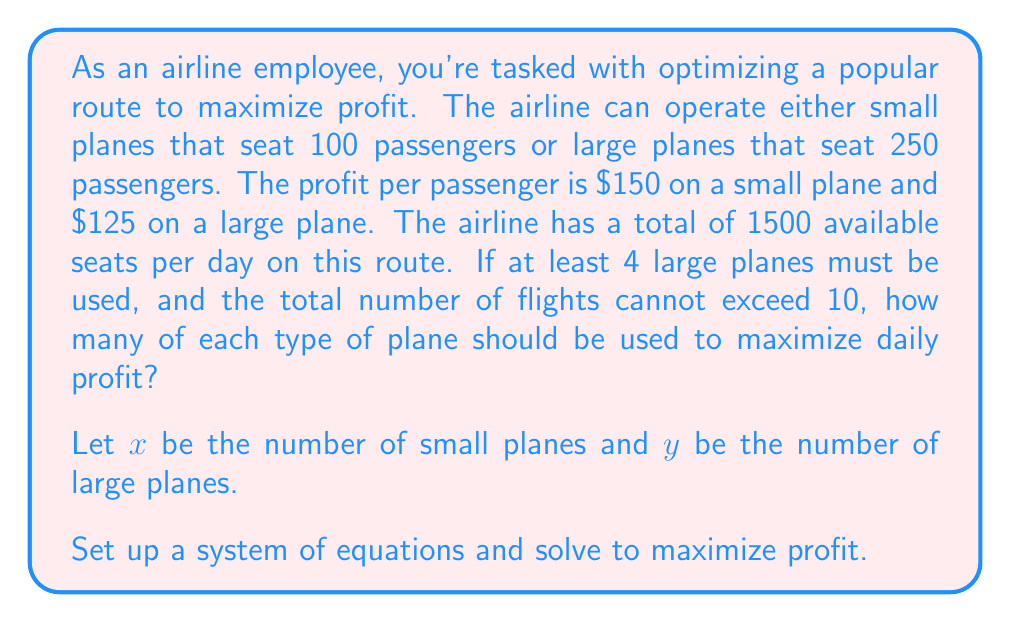Show me your answer to this math problem. Let's approach this step-by-step:

1) First, let's define our constraints:

   a) Total seats: $100x + 250y \leq 1500$
   b) At least 4 large planes: $y \geq 4$
   c) Total flights not exceeding 10: $x + y \leq 10$
   d) Non-negativity: $x \geq 0, y \geq 0$

2) Our objective function (profit) is:
   $P = 150(100x) + 125(250y) = 15000x + 31250y$

3) We need to maximize P subject to our constraints. Let's start by graphing our constraints:

   [asy]
   import graph;
   size(200,200);
   
   xaxis("x",0,10);
   yaxis("y",0,10);
   
   draw((0,6)--(15,0),blue);
   draw((0,4)--(0,10),red);
   draw((0,10)--(10,0),green);
   
   label("100x + 250y = 1500",(-1,7),blue);
   label("y = 4",(1,4),red);
   label("x + y = 10",(5,6),green);
   
   fill((0,6)--(0,10)--(4,6)--(6,4)--(0,6),lightgray);
   [/asy]

4) The feasible region is the shaded area. The optimal solution will be at one of the corner points.

5) The corner points are (0,6), (0,10), (4,6), and (6,4).

6) Let's evaluate our profit function at each point:

   At (0,6): P = 15000(0) + 31250(6) = 187500
   At (0,10): P = 15000(0) + 31250(10) = 312500
   At (4,6): P = 15000(4) + 31250(6) = 247500
   At (6,4): P = 15000(6) + 31250(4) = 215000

7) The maximum profit occurs at the point (0,10), which means using 10 large planes and 0 small planes.
Answer: To maximize daily profit, the airline should use 10 large planes and 0 small planes, resulting in a maximum profit of $312,500 per day. 